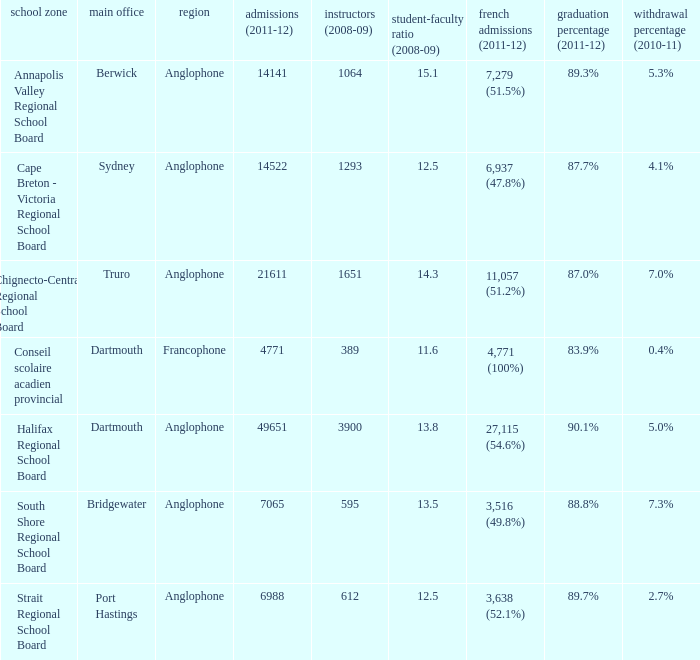What is their withdrawal rate for the school district with headquarters located in Truro? 7.0%. 